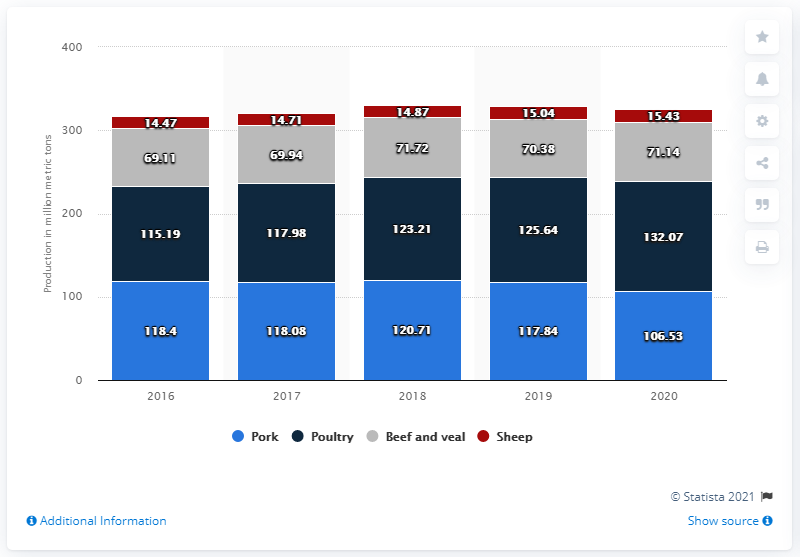Mention a couple of crucial points in this snapshot. In 2020, it is projected that the world's production of beef and veal will reach 71.72 million metric tons. 